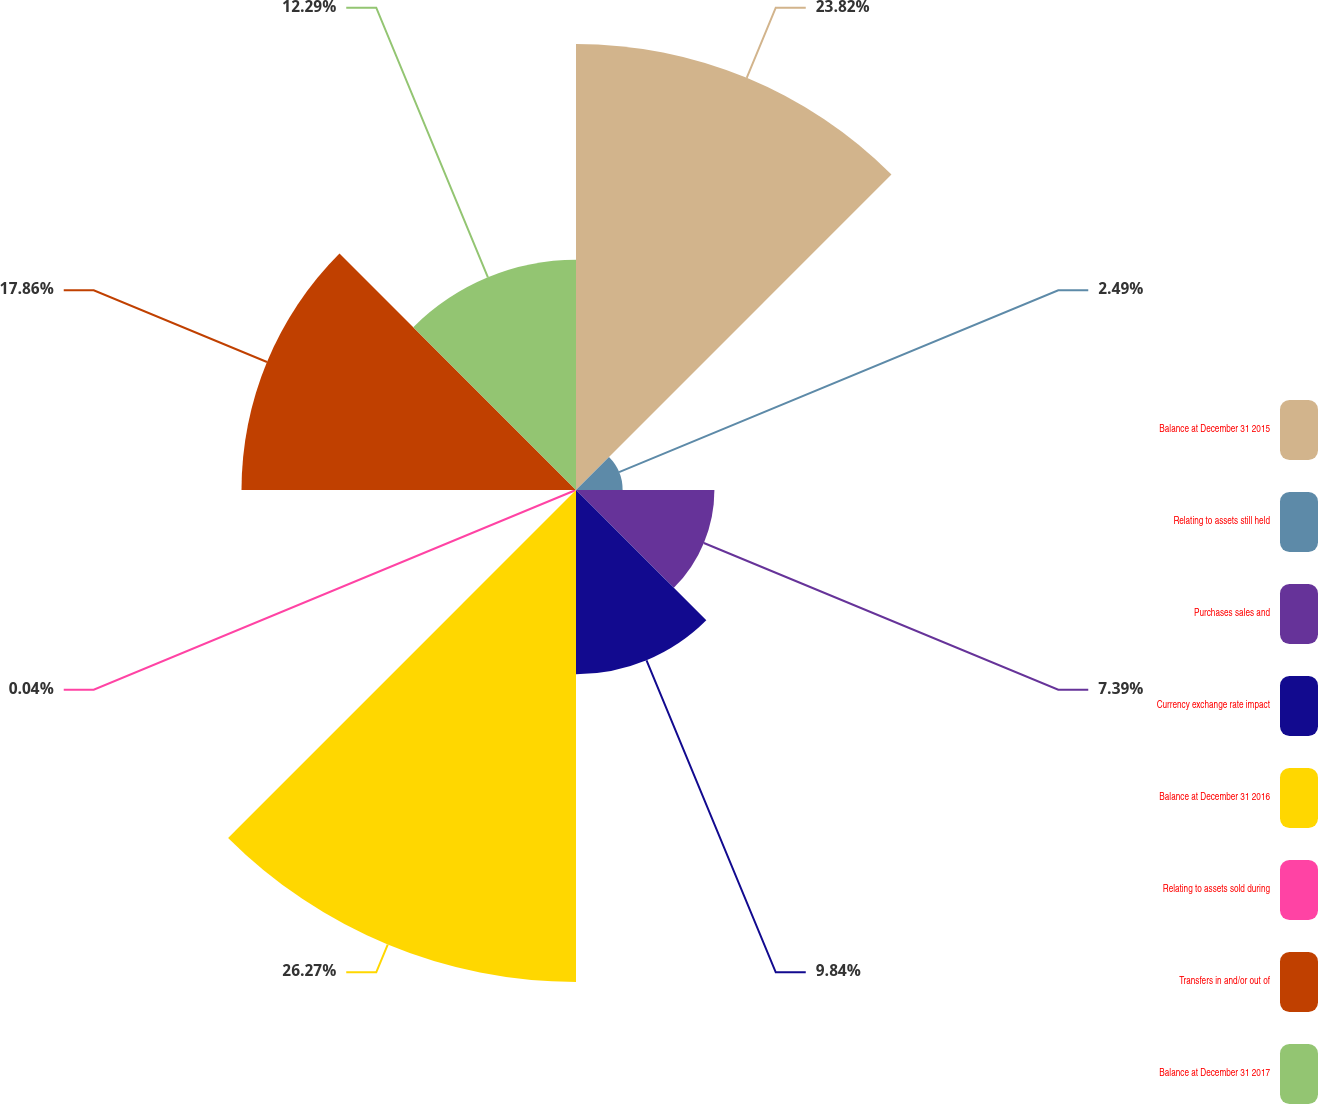<chart> <loc_0><loc_0><loc_500><loc_500><pie_chart><fcel>Balance at December 31 2015<fcel>Relating to assets still held<fcel>Purchases sales and<fcel>Currency exchange rate impact<fcel>Balance at December 31 2016<fcel>Relating to assets sold during<fcel>Transfers in and/or out of<fcel>Balance at December 31 2017<nl><fcel>23.82%<fcel>2.49%<fcel>7.39%<fcel>9.84%<fcel>26.27%<fcel>0.04%<fcel>17.86%<fcel>12.29%<nl></chart> 